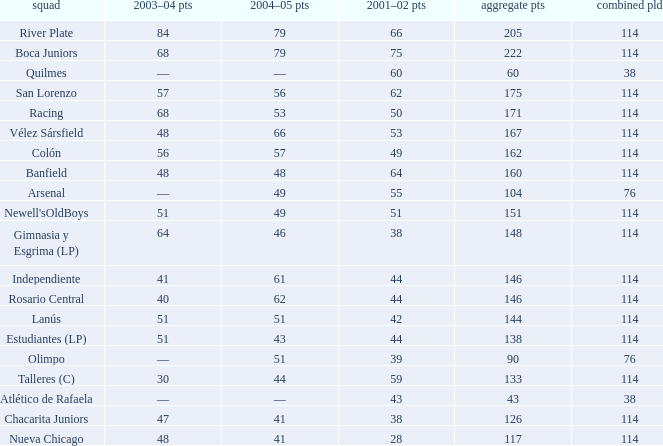Which Total Pts have a 2001–02 Pts smaller than 38? 117.0. 